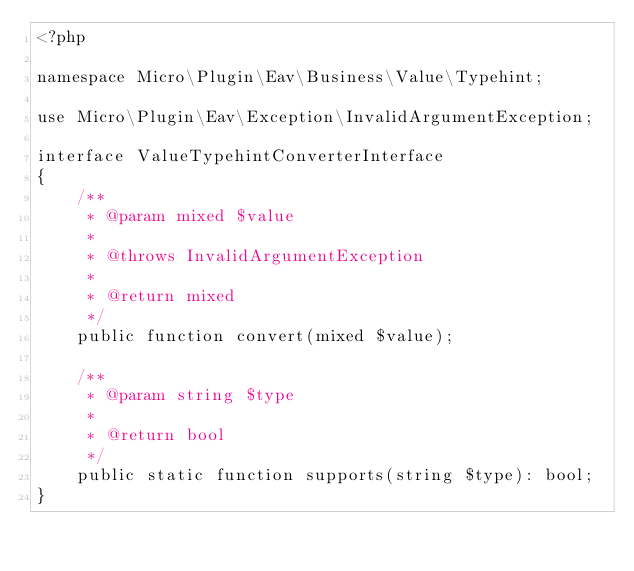<code> <loc_0><loc_0><loc_500><loc_500><_PHP_><?php

namespace Micro\Plugin\Eav\Business\Value\Typehint;

use Micro\Plugin\Eav\Exception\InvalidArgumentException;

interface ValueTypehintConverterInterface
{
    /**
     * @param mixed $value
     *
     * @throws InvalidArgumentException
     *
     * @return mixed
     */
    public function convert(mixed $value);

    /**
     * @param string $type
     *
     * @return bool
     */
    public static function supports(string $type): bool;
}
</code> 